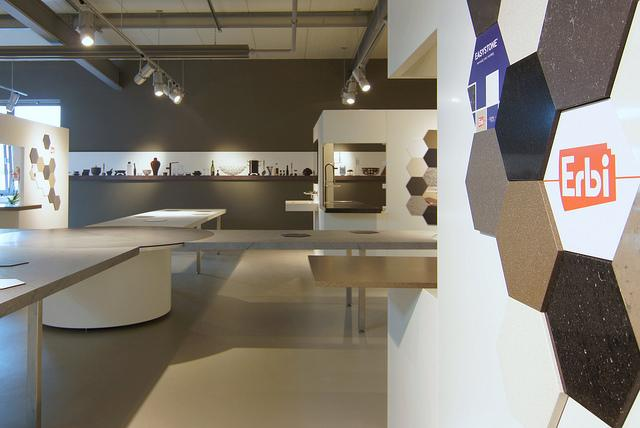This showroom specializes in which home renovation product? Please explain your reasoning. kitchen counters. These counters are on display so people can see them and pick out what they like. 